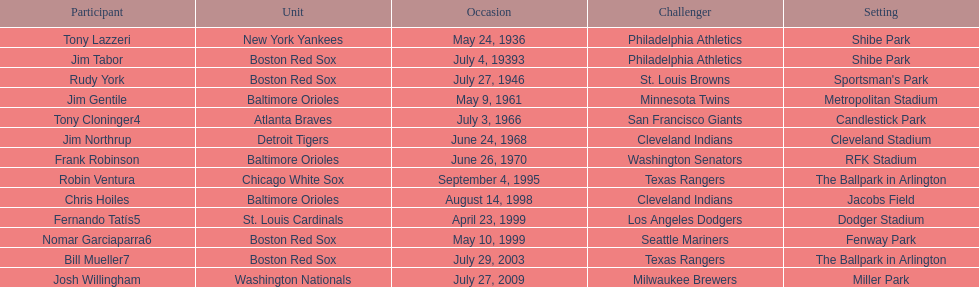What is the number of times a boston red sox player has had two grand slams in one game? 4. 